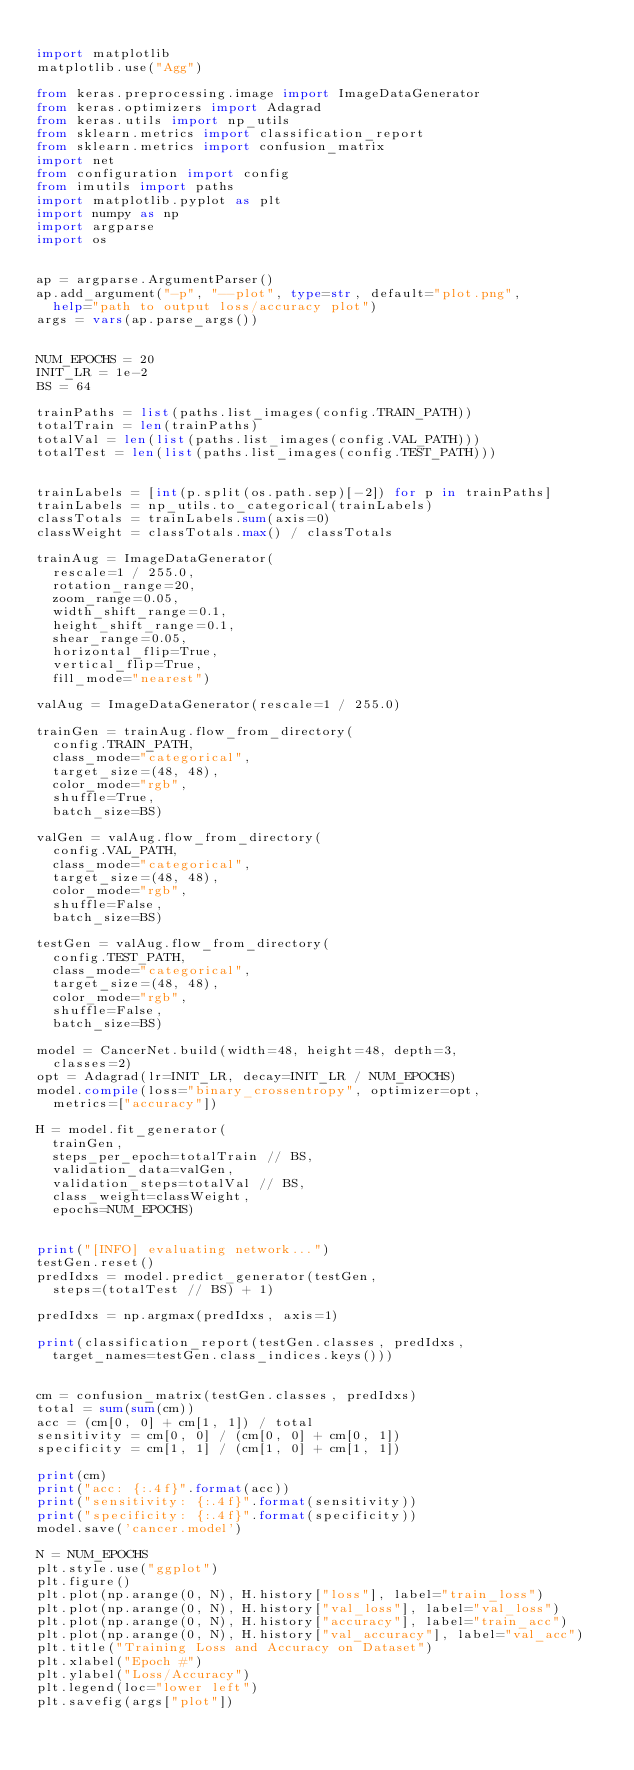Convert code to text. <code><loc_0><loc_0><loc_500><loc_500><_Python_>
import matplotlib
matplotlib.use("Agg")

from keras.preprocessing.image import ImageDataGenerator
from keras.optimizers import Adagrad
from keras.utils import np_utils
from sklearn.metrics import classification_report
from sklearn.metrics import confusion_matrix
import net
from configuration import config
from imutils import paths
import matplotlib.pyplot as plt
import numpy as np
import argparse
import os


ap = argparse.ArgumentParser()
ap.add_argument("-p", "--plot", type=str, default="plot.png",
	help="path to output loss/accuracy plot")
args = vars(ap.parse_args())


NUM_EPOCHS = 20
INIT_LR = 1e-2
BS = 64

trainPaths = list(paths.list_images(config.TRAIN_PATH))
totalTrain = len(trainPaths)
totalVal = len(list(paths.list_images(config.VAL_PATH)))
totalTest = len(list(paths.list_images(config.TEST_PATH)))


trainLabels = [int(p.split(os.path.sep)[-2]) for p in trainPaths]
trainLabels = np_utils.to_categorical(trainLabels)
classTotals = trainLabels.sum(axis=0)
classWeight = classTotals.max() / classTotals

trainAug = ImageDataGenerator(
	rescale=1 / 255.0,
	rotation_range=20,
	zoom_range=0.05,
	width_shift_range=0.1,
	height_shift_range=0.1,
	shear_range=0.05,
	horizontal_flip=True,
	vertical_flip=True,
	fill_mode="nearest")

valAug = ImageDataGenerator(rescale=1 / 255.0)

trainGen = trainAug.flow_from_directory(
	config.TRAIN_PATH,
	class_mode="categorical",
	target_size=(48, 48),
	color_mode="rgb",
	shuffle=True,
	batch_size=BS)

valGen = valAug.flow_from_directory(
	config.VAL_PATH,
	class_mode="categorical",
	target_size=(48, 48),
	color_mode="rgb",
	shuffle=False,
	batch_size=BS)

testGen = valAug.flow_from_directory(
	config.TEST_PATH,
	class_mode="categorical",
	target_size=(48, 48),
	color_mode="rgb",
	shuffle=False,
	batch_size=BS)

model = CancerNet.build(width=48, height=48, depth=3,
	classes=2)
opt = Adagrad(lr=INIT_LR, decay=INIT_LR / NUM_EPOCHS)
model.compile(loss="binary_crossentropy", optimizer=opt,
	metrics=["accuracy"])

H = model.fit_generator(
	trainGen,
	steps_per_epoch=totalTrain // BS,
	validation_data=valGen,
	validation_steps=totalVal // BS,
	class_weight=classWeight,
	epochs=NUM_EPOCHS)


print("[INFO] evaluating network...")
testGen.reset()
predIdxs = model.predict_generator(testGen,
	steps=(totalTest // BS) + 1)

predIdxs = np.argmax(predIdxs, axis=1)

print(classification_report(testGen.classes, predIdxs,
	target_names=testGen.class_indices.keys()))


cm = confusion_matrix(testGen.classes, predIdxs)
total = sum(sum(cm))
acc = (cm[0, 0] + cm[1, 1]) / total
sensitivity = cm[0, 0] / (cm[0, 0] + cm[0, 1])
specificity = cm[1, 1] / (cm[1, 0] + cm[1, 1])

print(cm)
print("acc: {:.4f}".format(acc))
print("sensitivity: {:.4f}".format(sensitivity))
print("specificity: {:.4f}".format(specificity))
model.save('cancer.model')

N = NUM_EPOCHS
plt.style.use("ggplot")
plt.figure()
plt.plot(np.arange(0, N), H.history["loss"], label="train_loss")
plt.plot(np.arange(0, N), H.history["val_loss"], label="val_loss")
plt.plot(np.arange(0, N), H.history["accuracy"], label="train_acc")
plt.plot(np.arange(0, N), H.history["val_accuracy"], label="val_acc")
plt.title("Training Loss and Accuracy on Dataset")
plt.xlabel("Epoch #")
plt.ylabel("Loss/Accuracy")
plt.legend(loc="lower left")
plt.savefig(args["plot"])
</code> 